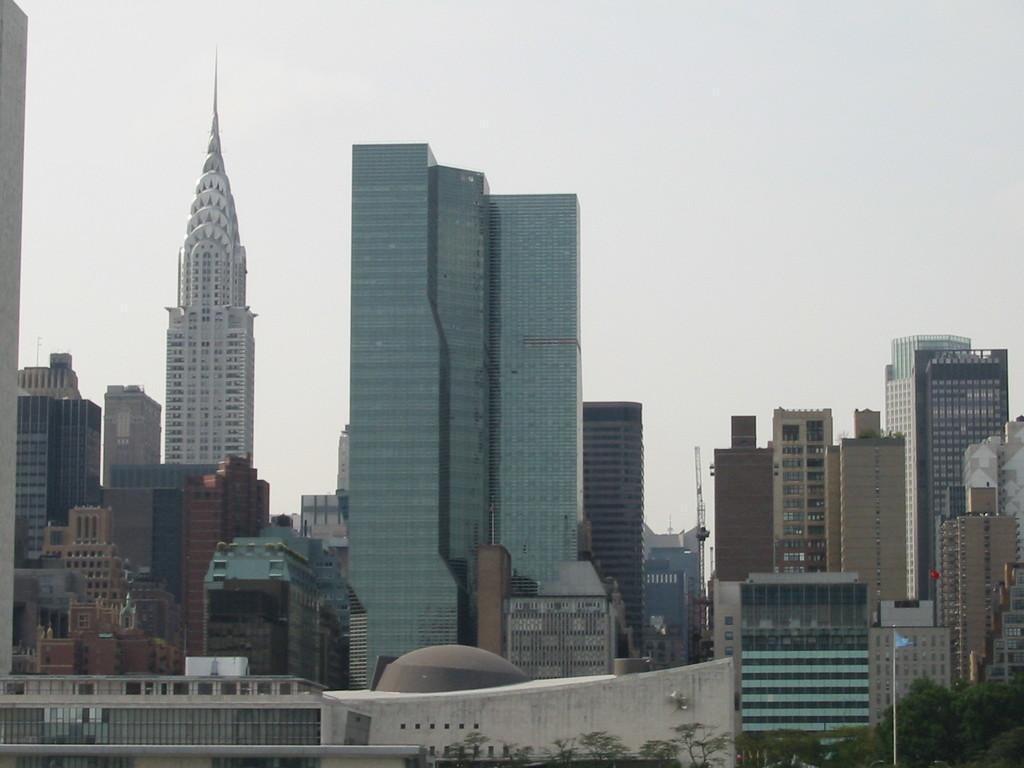What type of structures can be seen in the image? There are buildings visible in the image. What is located in front of the buildings? There are trees in front of the buildings. What is the color of the flag in the image? The flag in the image is blue. How would you describe the color of the sky in the image? The sky appears to be white in color. Can you see a woman touching the island in the image? There is no woman or island present in the image. 